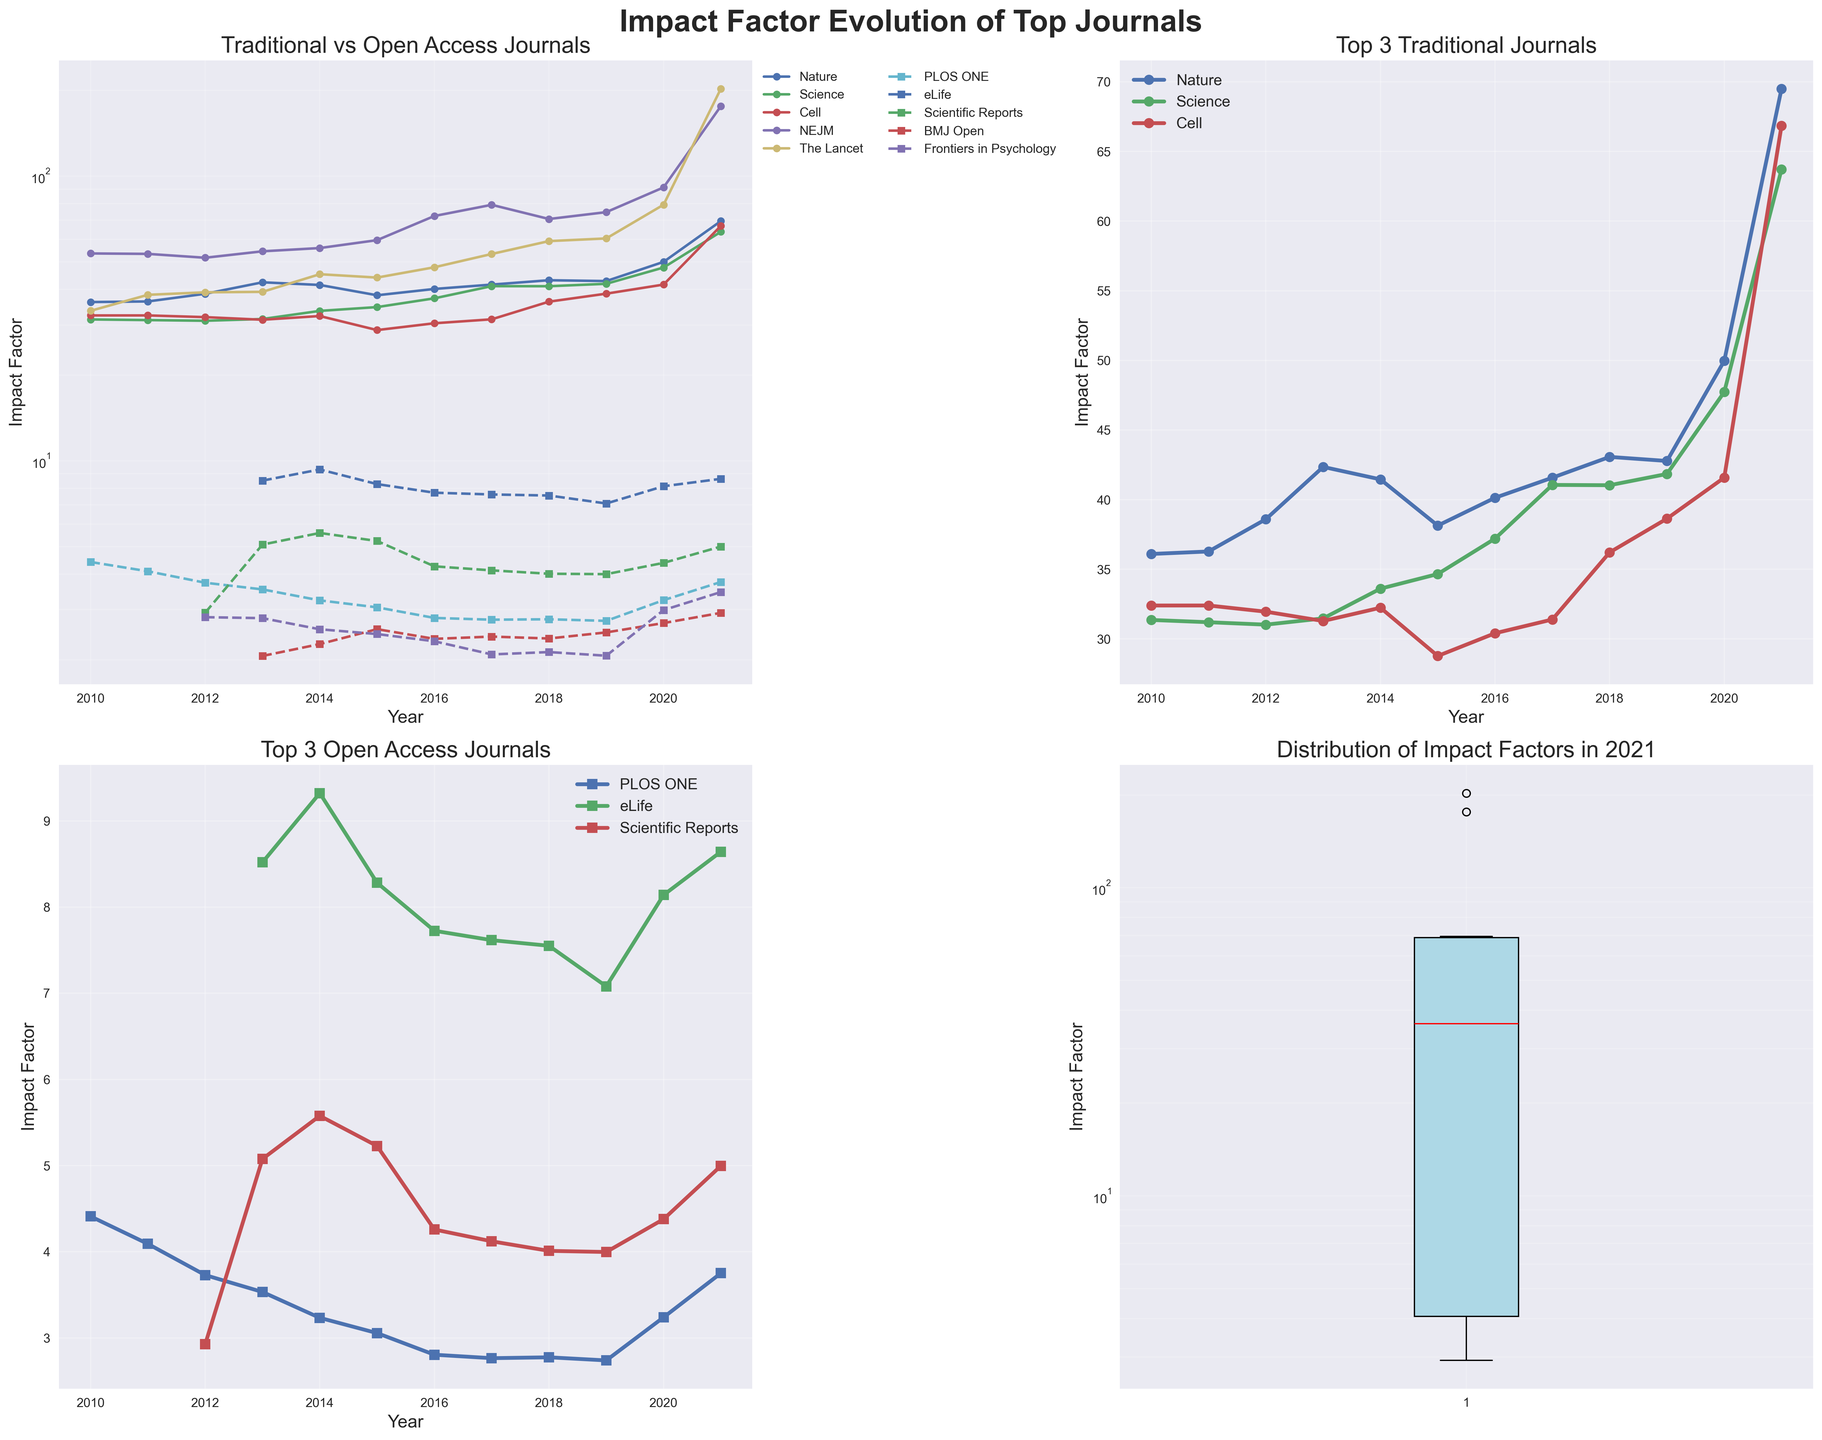What is the impact factor trend of Nature vs PLOS ONE from 2010 to 2021? Nature's impact factor shows a general upward trend, starting at 36.101 in 2010 and peaking at 69.504 in 2021. PLOS ONE's impact factor, on the other hand, has a downward trend starting at 4.411 in 2010 and declining to 3.752 in 2021.
Answer: Nature: Upward, PLOS ONE: Downward Which journal had the highest impact factor in 2021? From the Boxplot of Impact Factors in 2021, NEJM (New England Journal of Medicine) has the highest impact factor of 176.079.
Answer: NEJM How does the impact factor of eLife change from 2014 to 2021? eLife's impact factor starts at 9.322 in 2014, slightly fluctuates over the years, and finally reaches 8.642 in 2021.
Answer: Starts: 9.322 (2014), Ends: 8.642 (2021) Between 2010 and 2021, which traditional journal shows the steepest rise in impact factor? NEJM shows the steepest rise in impact factor, starting at 53.484 in 2010 and dramatically increasing to 176.079 in 2021.
Answer: NEJM What can be inferred from the impact factors of BMJ Open over the years? BMJ Open starts to appear in the data in 2013 with an impact factor of 2.063 and shows a generally increasing trend, finishing at 2.923 in 2021.
Answer: Increasing trend Compare the impact factors of The Lancet and Scientific Reports in 2020 and 2021. Which journal showed more growth? In 2020, The Lancet had an impact factor of 79.321, which increased to 202.731 in 2021. Scientific Reports had an impact factor of 4.379 in 2020 that grew to 4.997 in 2021. The Lancet showed a more significant growth.
Answer: The Lancet What do the boxplot of impact factors in 2021 suggest about the distribution? The 2021 boxplot indicates a wide range of impact factors, with NEJM having the highest and Frontiers in Psychology with one of the lowest. Most journals fall within a lower range, suggesting a skewed distribution.
Answer: Skewed distribution with high outliers 